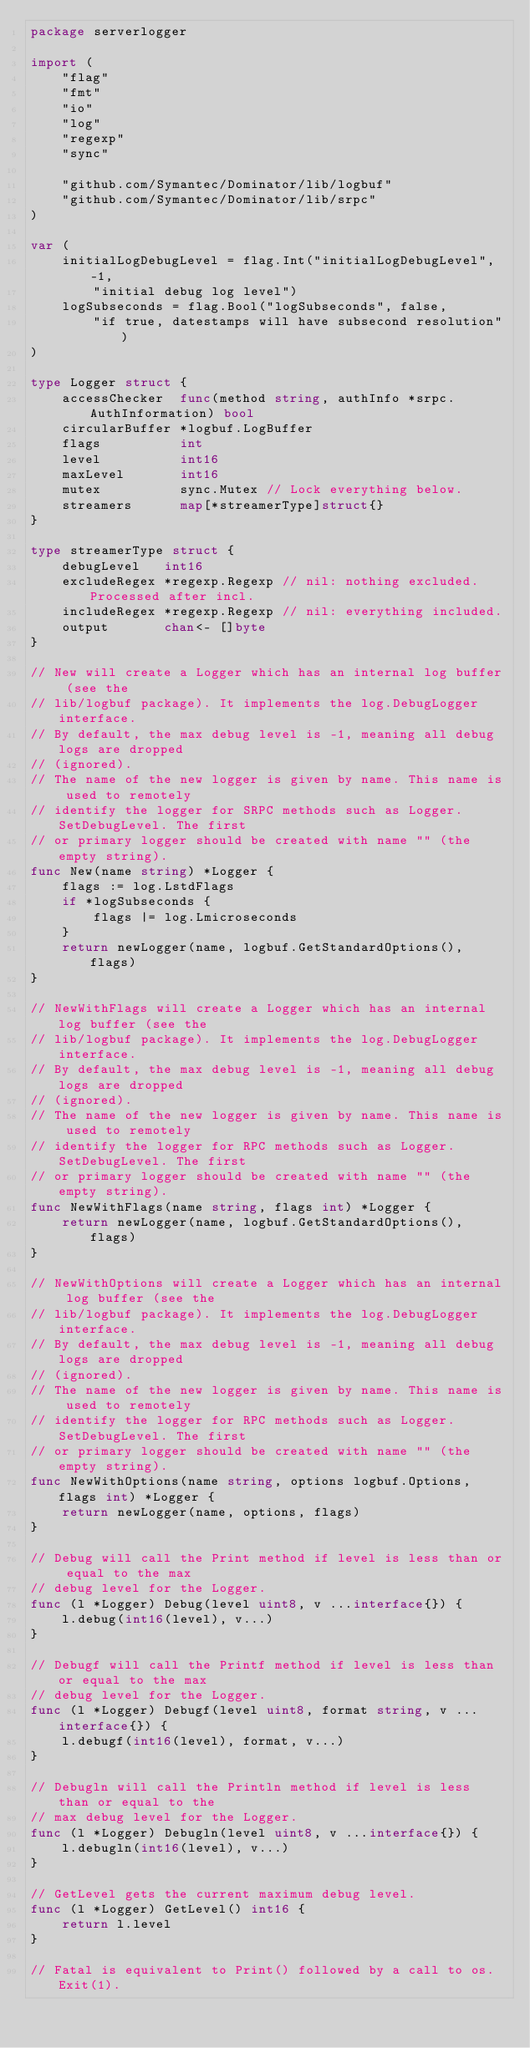Convert code to text. <code><loc_0><loc_0><loc_500><loc_500><_Go_>package serverlogger

import (
	"flag"
	"fmt"
	"io"
	"log"
	"regexp"
	"sync"

	"github.com/Symantec/Dominator/lib/logbuf"
	"github.com/Symantec/Dominator/lib/srpc"
)

var (
	initialLogDebugLevel = flag.Int("initialLogDebugLevel", -1,
		"initial debug log level")
	logSubseconds = flag.Bool("logSubseconds", false,
		"if true, datestamps will have subsecond resolution")
)

type Logger struct {
	accessChecker  func(method string, authInfo *srpc.AuthInformation) bool
	circularBuffer *logbuf.LogBuffer
	flags          int
	level          int16
	maxLevel       int16
	mutex          sync.Mutex // Lock everything below.
	streamers      map[*streamerType]struct{}
}

type streamerType struct {
	debugLevel   int16
	excludeRegex *regexp.Regexp // nil: nothing excluded. Processed after incl.
	includeRegex *regexp.Regexp // nil: everything included.
	output       chan<- []byte
}

// New will create a Logger which has an internal log buffer (see the
// lib/logbuf package). It implements the log.DebugLogger interface.
// By default, the max debug level is -1, meaning all debug logs are dropped
// (ignored).
// The name of the new logger is given by name. This name is used to remotely
// identify the logger for SRPC methods such as Logger.SetDebugLevel. The first
// or primary logger should be created with name "" (the empty string).
func New(name string) *Logger {
	flags := log.LstdFlags
	if *logSubseconds {
		flags |= log.Lmicroseconds
	}
	return newLogger(name, logbuf.GetStandardOptions(), flags)
}

// NewWithFlags will create a Logger which has an internal log buffer (see the
// lib/logbuf package). It implements the log.DebugLogger interface.
// By default, the max debug level is -1, meaning all debug logs are dropped
// (ignored).
// The name of the new logger is given by name. This name is used to remotely
// identify the logger for RPC methods such as Logger.SetDebugLevel. The first
// or primary logger should be created with name "" (the empty string).
func NewWithFlags(name string, flags int) *Logger {
	return newLogger(name, logbuf.GetStandardOptions(), flags)
}

// NewWithOptions will create a Logger which has an internal log buffer (see the
// lib/logbuf package). It implements the log.DebugLogger interface.
// By default, the max debug level is -1, meaning all debug logs are dropped
// (ignored).
// The name of the new logger is given by name. This name is used to remotely
// identify the logger for RPC methods such as Logger.SetDebugLevel. The first
// or primary logger should be created with name "" (the empty string).
func NewWithOptions(name string, options logbuf.Options, flags int) *Logger {
	return newLogger(name, options, flags)
}

// Debug will call the Print method if level is less than or equal to the max
// debug level for the Logger.
func (l *Logger) Debug(level uint8, v ...interface{}) {
	l.debug(int16(level), v...)
}

// Debugf will call the Printf method if level is less than or equal to the max
// debug level for the Logger.
func (l *Logger) Debugf(level uint8, format string, v ...interface{}) {
	l.debugf(int16(level), format, v...)
}

// Debugln will call the Println method if level is less than or equal to the
// max debug level for the Logger.
func (l *Logger) Debugln(level uint8, v ...interface{}) {
	l.debugln(int16(level), v...)
}

// GetLevel gets the current maximum debug level.
func (l *Logger) GetLevel() int16 {
	return l.level
}

// Fatal is equivalent to Print() followed by a call to os.Exit(1).</code> 